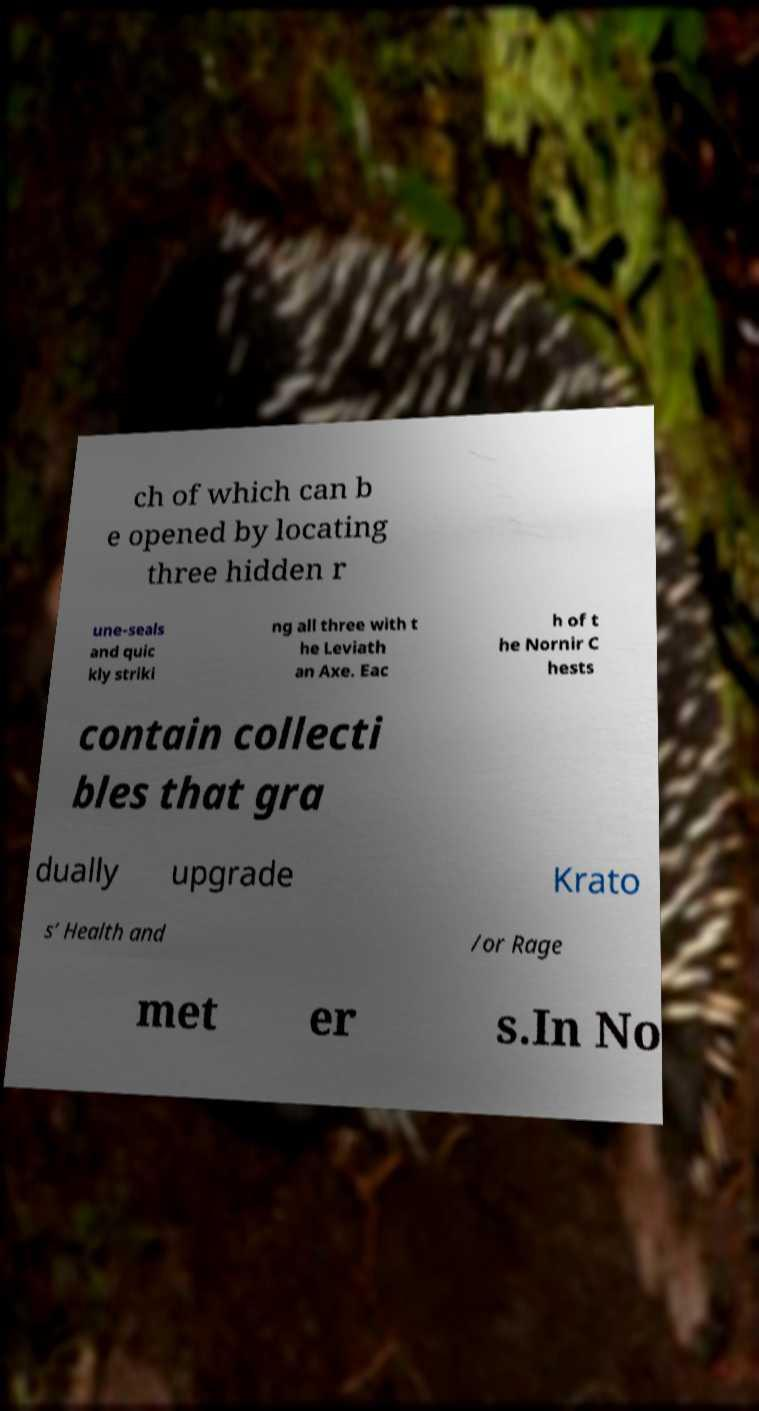Could you assist in decoding the text presented in this image and type it out clearly? ch of which can b e opened by locating three hidden r une-seals and quic kly striki ng all three with t he Leviath an Axe. Eac h of t he Nornir C hests contain collecti bles that gra dually upgrade Krato s’ Health and /or Rage met er s.In No 